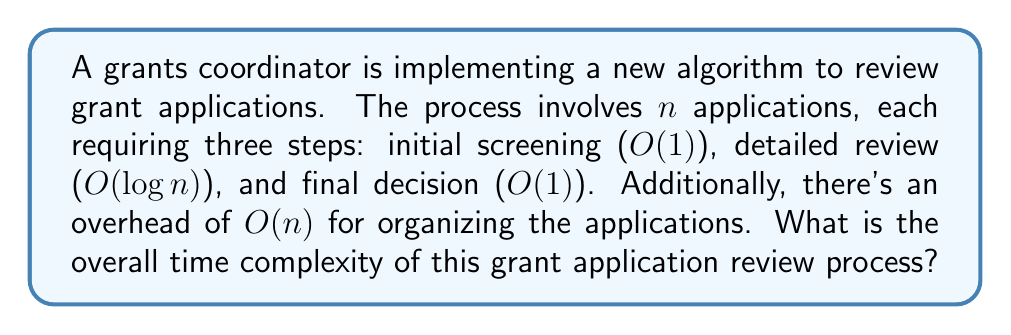Show me your answer to this math problem. To determine the overall time complexity, we need to analyze each step of the process and combine them:

1. Initial screening: $O(1)$ for each application
   Total for $n$ applications: $O(n)$

2. Detailed review: $O(\log n)$ for each application
   Total for $n$ applications: $O(n \log n)$

3. Final decision: $O(1)$ for each application
   Total for $n$ applications: $O(n)$

4. Overhead for organizing applications: $O(n)$

Now, we sum up all these components:

$$O(n) + O(n \log n) + O(n) + O(n)$$

Simplifying this expression:
- The $O(n \log n)$ term dominates all the $O(n)$ terms
- We can combine the $O(n)$ terms, but it doesn't affect the overall complexity

Therefore, the overall time complexity simplifies to $O(n \log n)$.

This means that as the number of grant applications ($n$) increases, the time taken by the review process grows at a rate of $n \log n$, which is more efficient than a quadratic growth ($n^2$) but less efficient than a linear growth ($n$).
Answer: $O(n \log n)$ 